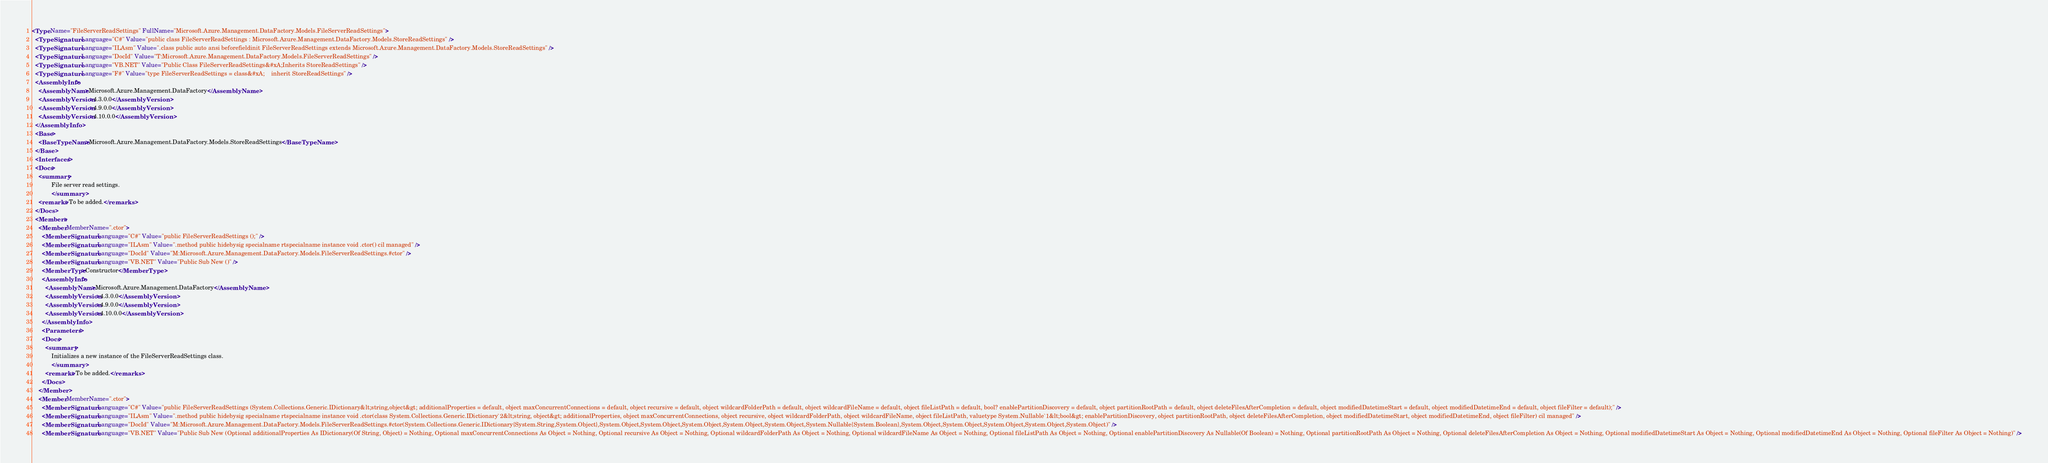<code> <loc_0><loc_0><loc_500><loc_500><_XML_><Type Name="FileServerReadSettings" FullName="Microsoft.Azure.Management.DataFactory.Models.FileServerReadSettings">
  <TypeSignature Language="C#" Value="public class FileServerReadSettings : Microsoft.Azure.Management.DataFactory.Models.StoreReadSettings" />
  <TypeSignature Language="ILAsm" Value=".class public auto ansi beforefieldinit FileServerReadSettings extends Microsoft.Azure.Management.DataFactory.Models.StoreReadSettings" />
  <TypeSignature Language="DocId" Value="T:Microsoft.Azure.Management.DataFactory.Models.FileServerReadSettings" />
  <TypeSignature Language="VB.NET" Value="Public Class FileServerReadSettings&#xA;Inherits StoreReadSettings" />
  <TypeSignature Language="F#" Value="type FileServerReadSettings = class&#xA;    inherit StoreReadSettings" />
  <AssemblyInfo>
    <AssemblyName>Microsoft.Azure.Management.DataFactory</AssemblyName>
    <AssemblyVersion>4.3.0.0</AssemblyVersion>
    <AssemblyVersion>4.9.0.0</AssemblyVersion>
    <AssemblyVersion>4.10.0.0</AssemblyVersion>
  </AssemblyInfo>
  <Base>
    <BaseTypeName>Microsoft.Azure.Management.DataFactory.Models.StoreReadSettings</BaseTypeName>
  </Base>
  <Interfaces />
  <Docs>
    <summary>
            File server read settings.
            </summary>
    <remarks>To be added.</remarks>
  </Docs>
  <Members>
    <Member MemberName=".ctor">
      <MemberSignature Language="C#" Value="public FileServerReadSettings ();" />
      <MemberSignature Language="ILAsm" Value=".method public hidebysig specialname rtspecialname instance void .ctor() cil managed" />
      <MemberSignature Language="DocId" Value="M:Microsoft.Azure.Management.DataFactory.Models.FileServerReadSettings.#ctor" />
      <MemberSignature Language="VB.NET" Value="Public Sub New ()" />
      <MemberType>Constructor</MemberType>
      <AssemblyInfo>
        <AssemblyName>Microsoft.Azure.Management.DataFactory</AssemblyName>
        <AssemblyVersion>4.3.0.0</AssemblyVersion>
        <AssemblyVersion>4.9.0.0</AssemblyVersion>
        <AssemblyVersion>4.10.0.0</AssemblyVersion>
      </AssemblyInfo>
      <Parameters />
      <Docs>
        <summary>
            Initializes a new instance of the FileServerReadSettings class.
            </summary>
        <remarks>To be added.</remarks>
      </Docs>
    </Member>
    <Member MemberName=".ctor">
      <MemberSignature Language="C#" Value="public FileServerReadSettings (System.Collections.Generic.IDictionary&lt;string,object&gt; additionalProperties = default, object maxConcurrentConnections = default, object recursive = default, object wildcardFolderPath = default, object wildcardFileName = default, object fileListPath = default, bool? enablePartitionDiscovery = default, object partitionRootPath = default, object deleteFilesAfterCompletion = default, object modifiedDatetimeStart = default, object modifiedDatetimeEnd = default, object fileFilter = default);" />
      <MemberSignature Language="ILAsm" Value=".method public hidebysig specialname rtspecialname instance void .ctor(class System.Collections.Generic.IDictionary`2&lt;string, object&gt; additionalProperties, object maxConcurrentConnections, object recursive, object wildcardFolderPath, object wildcardFileName, object fileListPath, valuetype System.Nullable`1&lt;bool&gt; enablePartitionDiscovery, object partitionRootPath, object deleteFilesAfterCompletion, object modifiedDatetimeStart, object modifiedDatetimeEnd, object fileFilter) cil managed" />
      <MemberSignature Language="DocId" Value="M:Microsoft.Azure.Management.DataFactory.Models.FileServerReadSettings.#ctor(System.Collections.Generic.IDictionary{System.String,System.Object},System.Object,System.Object,System.Object,System.Object,System.Object,System.Nullable{System.Boolean},System.Object,System.Object,System.Object,System.Object,System.Object)" />
      <MemberSignature Language="VB.NET" Value="Public Sub New (Optional additionalProperties As IDictionary(Of String, Object) = Nothing, Optional maxConcurrentConnections As Object = Nothing, Optional recursive As Object = Nothing, Optional wildcardFolderPath As Object = Nothing, Optional wildcardFileName As Object = Nothing, Optional fileListPath As Object = Nothing, Optional enablePartitionDiscovery As Nullable(Of Boolean) = Nothing, Optional partitionRootPath As Object = Nothing, Optional deleteFilesAfterCompletion As Object = Nothing, Optional modifiedDatetimeStart As Object = Nothing, Optional modifiedDatetimeEnd As Object = Nothing, Optional fileFilter As Object = Nothing)" /></code> 